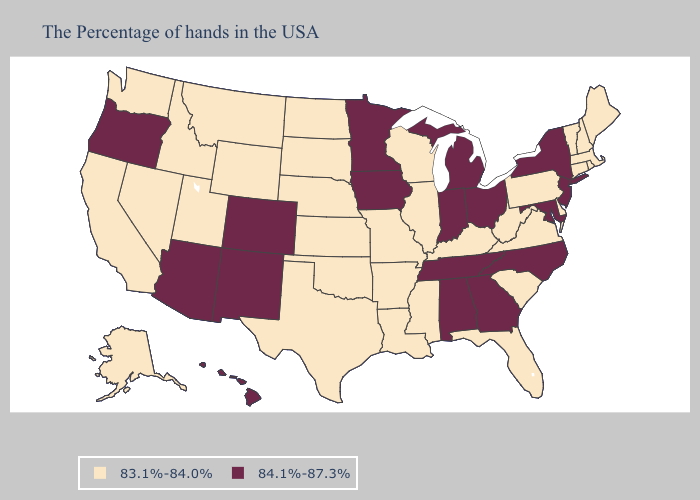What is the value of Michigan?
Concise answer only. 84.1%-87.3%. Does New York have the lowest value in the Northeast?
Write a very short answer. No. Does Oregon have the same value as Minnesota?
Write a very short answer. Yes. Name the states that have a value in the range 84.1%-87.3%?
Be succinct. New York, New Jersey, Maryland, North Carolina, Ohio, Georgia, Michigan, Indiana, Alabama, Tennessee, Minnesota, Iowa, Colorado, New Mexico, Arizona, Oregon, Hawaii. Which states hav the highest value in the West?
Write a very short answer. Colorado, New Mexico, Arizona, Oregon, Hawaii. Name the states that have a value in the range 84.1%-87.3%?
Quick response, please. New York, New Jersey, Maryland, North Carolina, Ohio, Georgia, Michigan, Indiana, Alabama, Tennessee, Minnesota, Iowa, Colorado, New Mexico, Arizona, Oregon, Hawaii. What is the highest value in the USA?
Keep it brief. 84.1%-87.3%. Does Arizona have the highest value in the West?
Answer briefly. Yes. Name the states that have a value in the range 84.1%-87.3%?
Be succinct. New York, New Jersey, Maryland, North Carolina, Ohio, Georgia, Michigan, Indiana, Alabama, Tennessee, Minnesota, Iowa, Colorado, New Mexico, Arizona, Oregon, Hawaii. Does Missouri have the lowest value in the MidWest?
Give a very brief answer. Yes. Name the states that have a value in the range 83.1%-84.0%?
Short answer required. Maine, Massachusetts, Rhode Island, New Hampshire, Vermont, Connecticut, Delaware, Pennsylvania, Virginia, South Carolina, West Virginia, Florida, Kentucky, Wisconsin, Illinois, Mississippi, Louisiana, Missouri, Arkansas, Kansas, Nebraska, Oklahoma, Texas, South Dakota, North Dakota, Wyoming, Utah, Montana, Idaho, Nevada, California, Washington, Alaska. Name the states that have a value in the range 84.1%-87.3%?
Be succinct. New York, New Jersey, Maryland, North Carolina, Ohio, Georgia, Michigan, Indiana, Alabama, Tennessee, Minnesota, Iowa, Colorado, New Mexico, Arizona, Oregon, Hawaii. Which states have the lowest value in the USA?
Quick response, please. Maine, Massachusetts, Rhode Island, New Hampshire, Vermont, Connecticut, Delaware, Pennsylvania, Virginia, South Carolina, West Virginia, Florida, Kentucky, Wisconsin, Illinois, Mississippi, Louisiana, Missouri, Arkansas, Kansas, Nebraska, Oklahoma, Texas, South Dakota, North Dakota, Wyoming, Utah, Montana, Idaho, Nevada, California, Washington, Alaska. Name the states that have a value in the range 83.1%-84.0%?
Quick response, please. Maine, Massachusetts, Rhode Island, New Hampshire, Vermont, Connecticut, Delaware, Pennsylvania, Virginia, South Carolina, West Virginia, Florida, Kentucky, Wisconsin, Illinois, Mississippi, Louisiana, Missouri, Arkansas, Kansas, Nebraska, Oklahoma, Texas, South Dakota, North Dakota, Wyoming, Utah, Montana, Idaho, Nevada, California, Washington, Alaska. Does Florida have the same value as Kentucky?
Short answer required. Yes. 